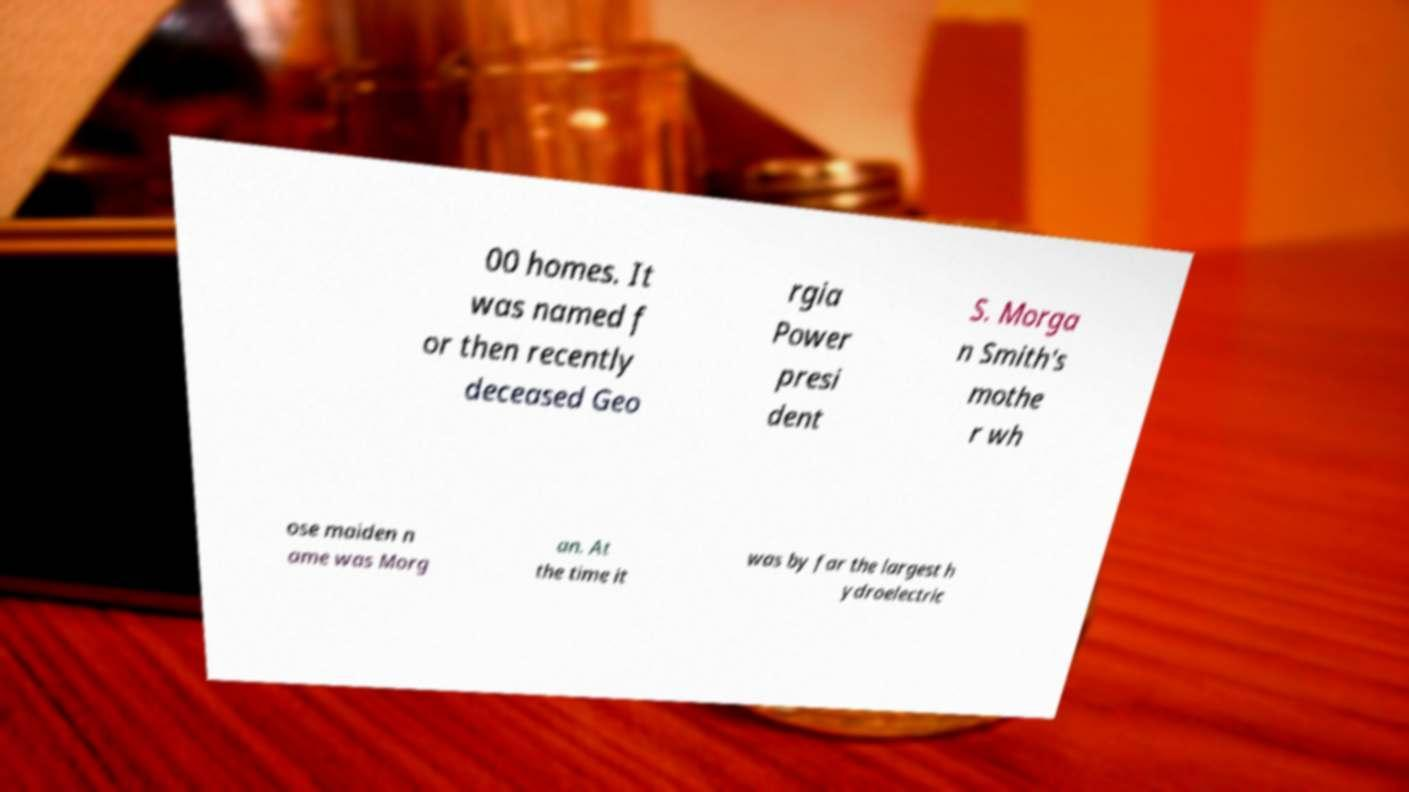What messages or text are displayed in this image? I need them in a readable, typed format. 00 homes. It was named f or then recently deceased Geo rgia Power presi dent S. Morga n Smith's mothe r wh ose maiden n ame was Morg an. At the time it was by far the largest h ydroelectric 